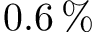Convert formula to latex. <formula><loc_0><loc_0><loc_500><loc_500>0 . 6 \, \%</formula> 